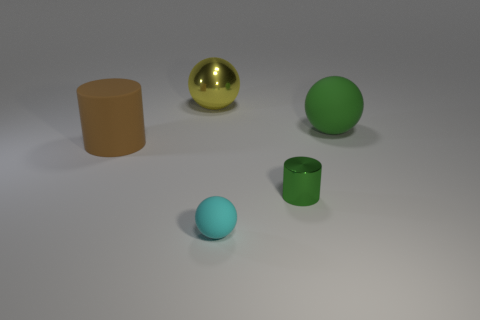There is a large brown matte object; what shape is it?
Your answer should be very brief. Cylinder. What material is the big thing that is left of the big yellow sphere?
Give a very brief answer. Rubber. There is a cylinder that is to the right of the large rubber object on the left side of the metallic object left of the small green metal cylinder; what is its color?
Your response must be concise. Green. There is a metallic thing that is the same size as the cyan sphere; what is its color?
Give a very brief answer. Green. What number of rubber objects are small green objects or cyan balls?
Give a very brief answer. 1. What color is the big thing that is the same material as the tiny cylinder?
Your answer should be compact. Yellow. There is a green thing behind the big brown matte thing behind the tiny cyan object; what is its material?
Give a very brief answer. Rubber. How many objects are either tiny things in front of the small cylinder or things in front of the shiny cylinder?
Your response must be concise. 1. How big is the green thing to the left of the big ball in front of the big sphere to the left of the small matte thing?
Your answer should be compact. Small. Are there the same number of large yellow balls on the left side of the brown matte object and blue balls?
Your answer should be compact. Yes. 